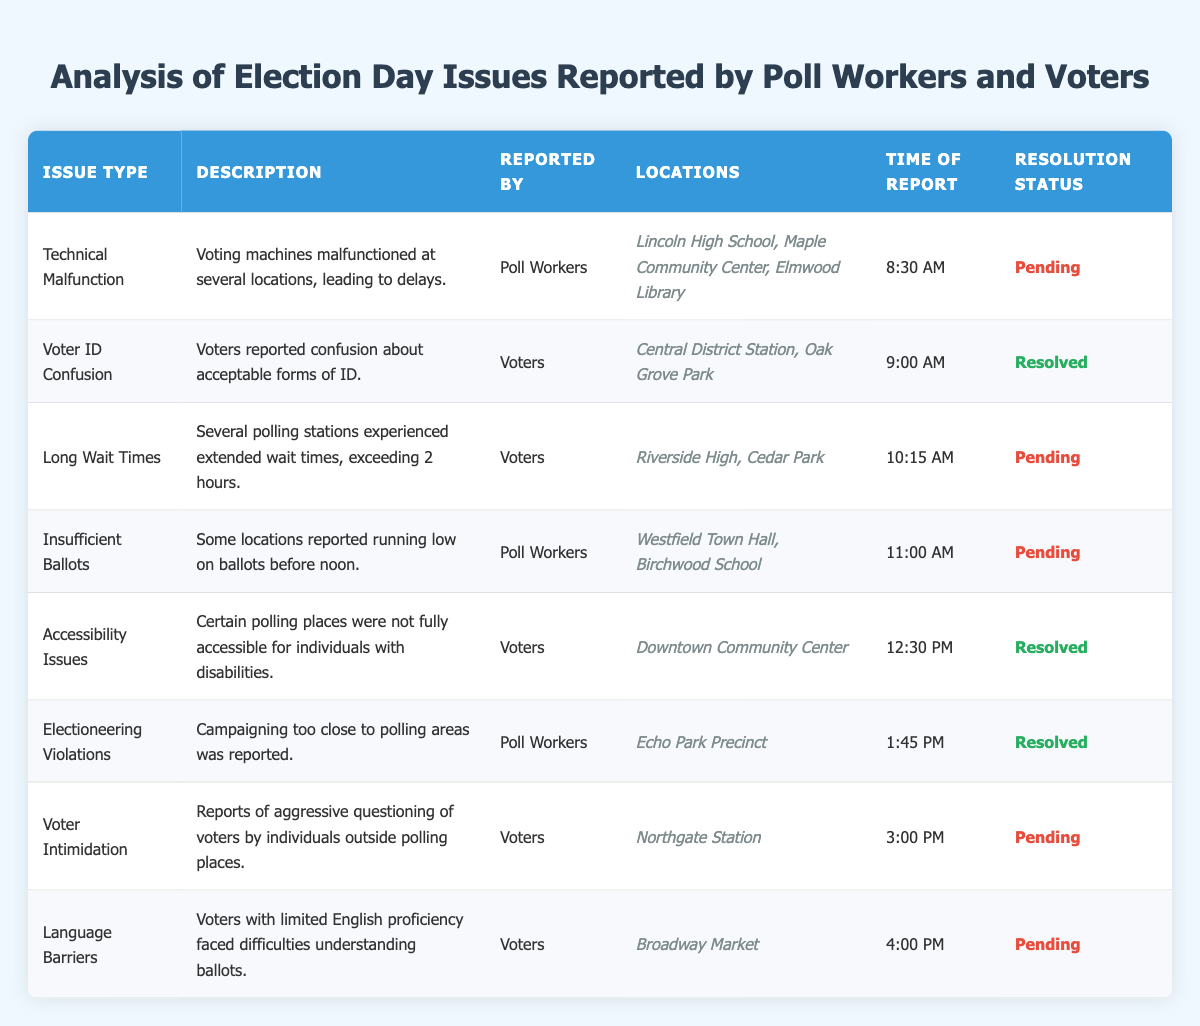What is the total number of issues reported by voters? In the table, the issues reported specifically by voters include Voter ID Confusion, Long Wait Times, Accessibility Issues, Voter Intimidation, and Language Barriers. This amounts to 5 issues total.
Answer: 5 How many issues have a resolution status of "Pending"? By examining the table, we can count the issues with a status of "Pending," which are Technical Malfunction, Long Wait Times, Insufficient Ballots, Voter Intimidation, and Language Barriers. There are a total of 5 pending issues.
Answer: 5 Which polling location reported the issue of "Insufficient Ballots"? The issue of "Insufficient Ballots" was reported at Westfield Town Hall and Birchwood School according to the table.
Answer: Westfield Town Hall and Birchwood School Did any issues reported by poll workers result in a "Resolved" status? Yes, according to the table, the issue of "Electioneering Violations" reported by poll workers has a status of "Resolved."
Answer: Yes What time was the earliest issue reported, and what was the issue type? The earliest issue reported was at 8:30 AM, which was a Technical Malfunction.
Answer: 8:30 AM, Technical Malfunction Calculate the difference in resolution status between the two categories of reporters (Poll Workers and Voters) in terms of resolved versus pending issues. For Poll Workers: 1 resolved (Electioneering Violations) and 3 pending (Technical Malfunction, Insufficient Ballots); for Voters: 2 resolved (Voter ID Confusion, Accessibility Issues) and 4 pending (Long Wait Times, Voter Intimidation, Language Barriers). There are 3 pending issues among Poll Workers and 4 among Voters, with Voters having 2 resolved issues to Poll Workers' 1. The difference in pending issues is 1 (4 Voter pending - 3 Poll Worker pending).
Answer: 1 What percentage of all reported issues were resolved? There are 8 total issues reported: 5 pending and 3 resolved (Voter ID Confusion, Accessibility Issues, Electioneering Violations). To find the percentage resolved: (3 resolved / 8 total) * 100 = 37.5%.
Answer: 37.5% Identify any polling locations that had reported issues and experienced long wait times. The issues of Long Wait Times were reported at Riverside High and Cedar Park. Both locations are listed in the data provided.
Answer: Riverside High and Cedar Park Which type of issue is reported the most among voter complaints? The most reported issue type among voters is related to Long Wait Times, with it being mentioned as one of the key complaints. Upon examining the data, there are 4 complaints related directly to voters that could indicate their concerns, which is the most compared to others.
Answer: Long Wait Times 